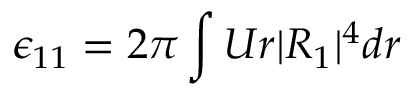<formula> <loc_0><loc_0><loc_500><loc_500>\epsilon _ { 1 1 } = 2 \pi \int U r | R _ { 1 } | ^ { 4 } d r</formula> 